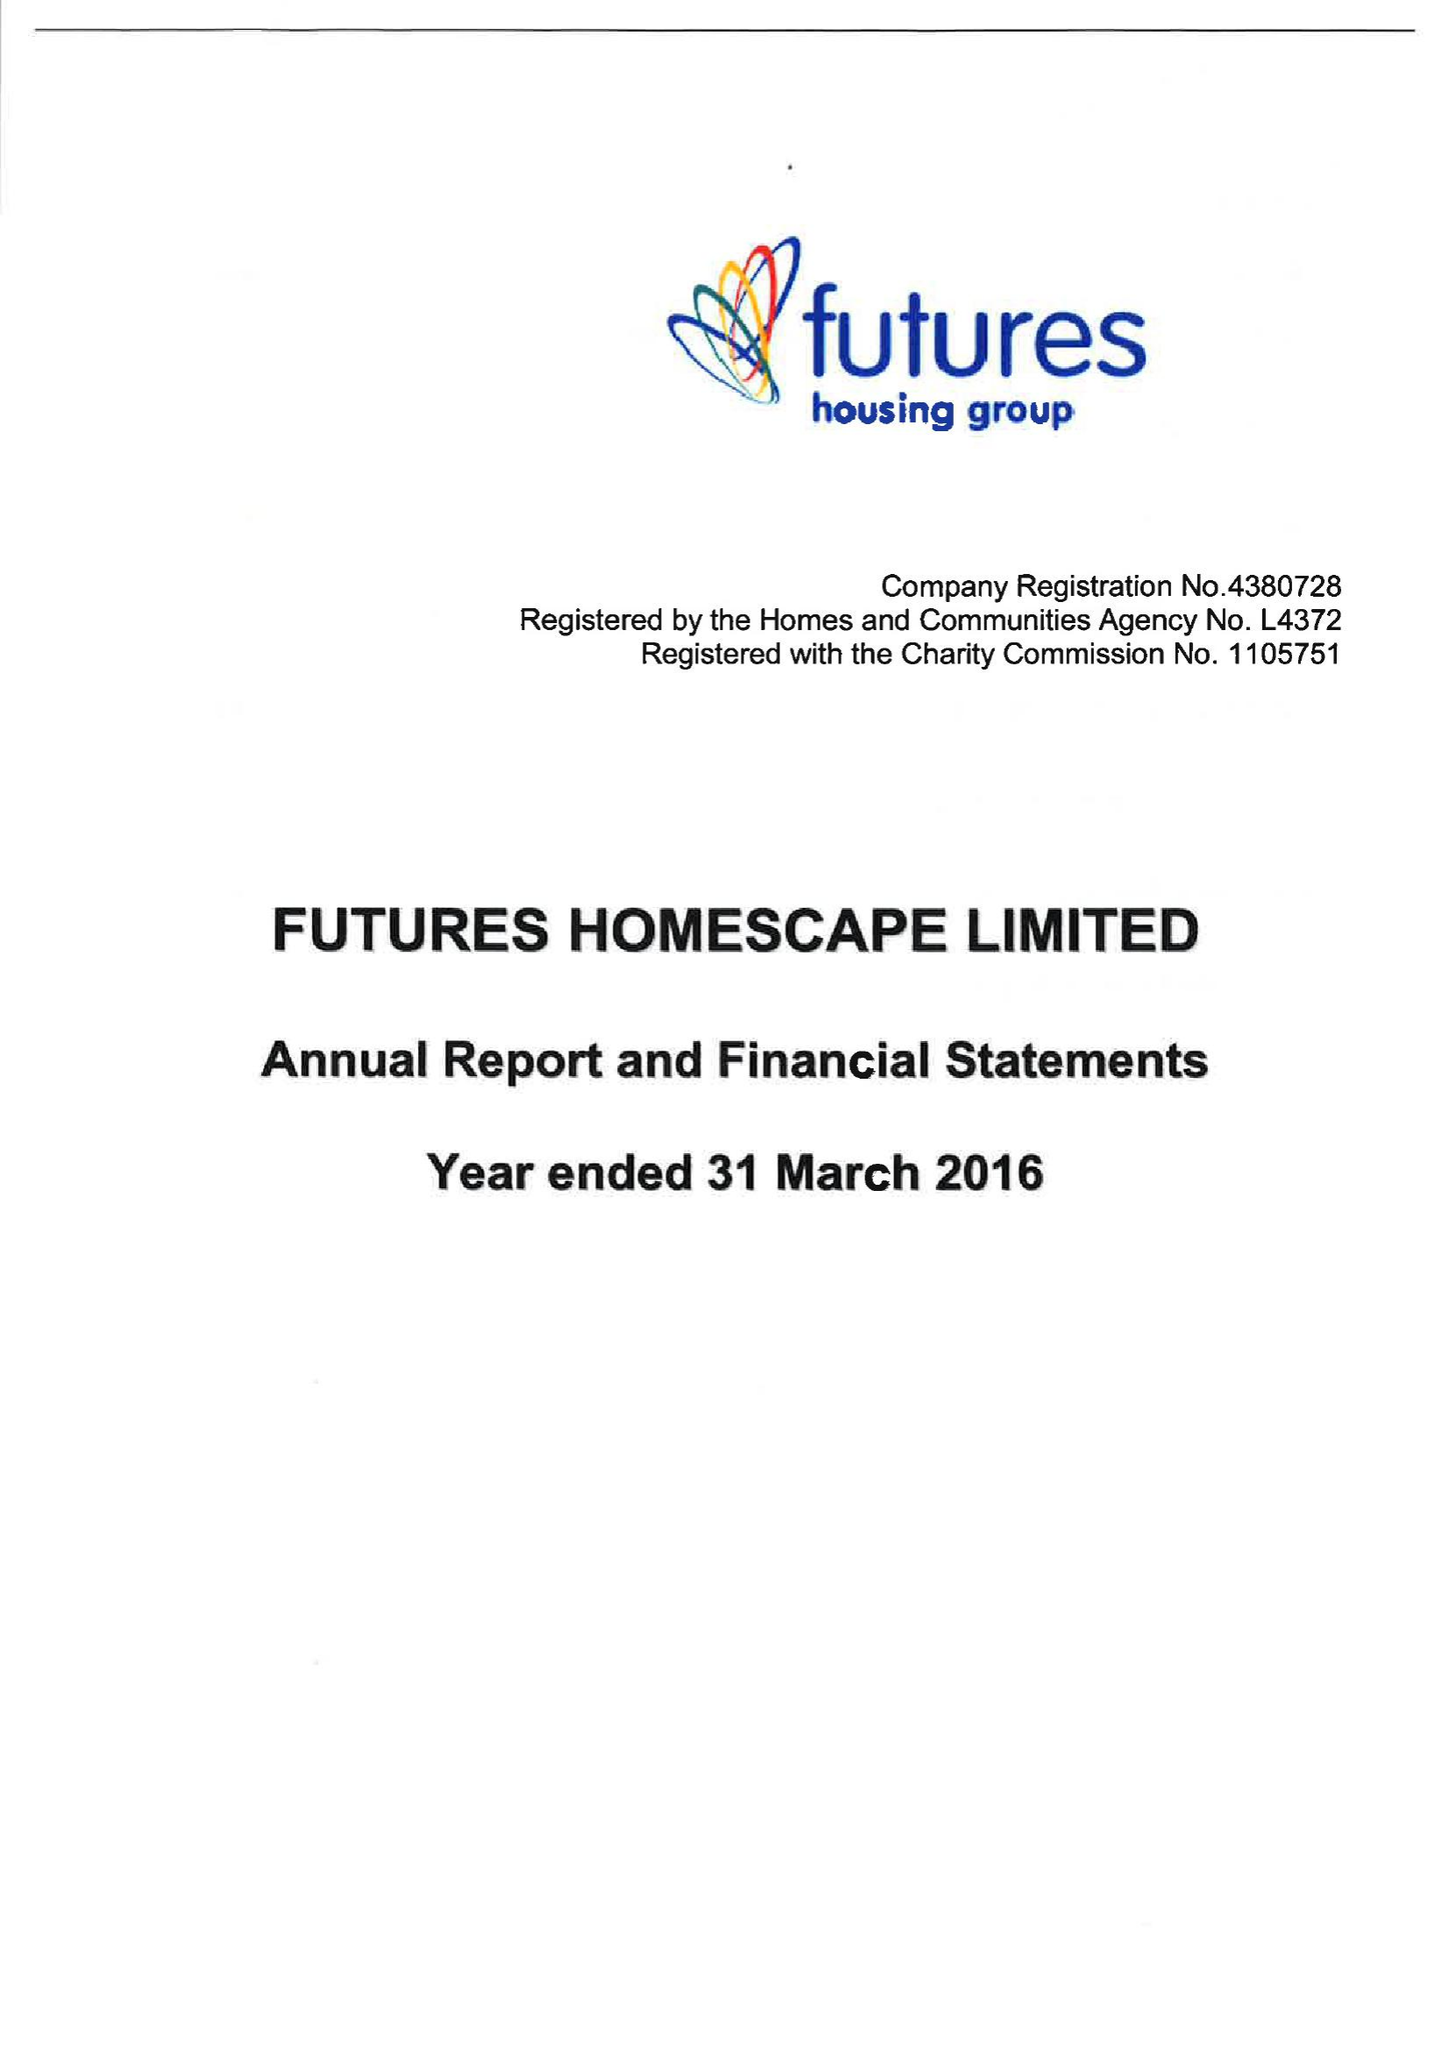What is the value for the address__post_town?
Answer the question using a single word or phrase. RIPLEY 